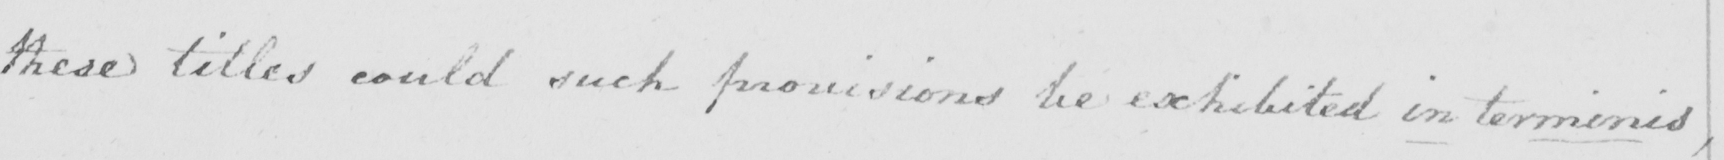What text is written in this handwritten line? these titles could such provisions be exhibited in terminis , 